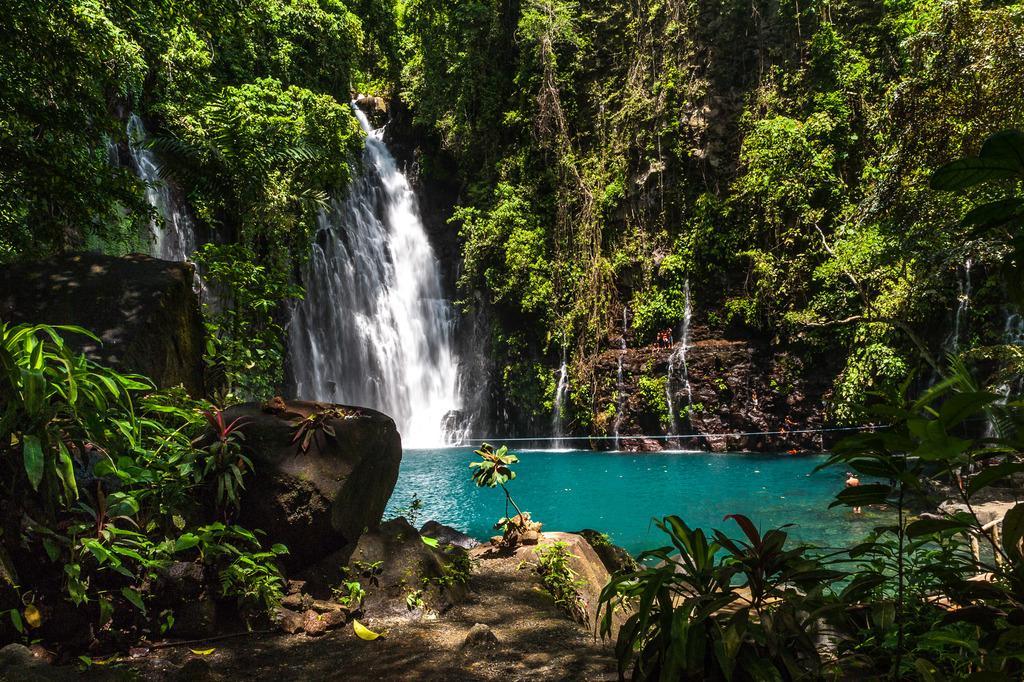How would you summarize this image in a sentence or two? In this picture there is a person standing in the water and there is a waterfall and there are trees on the hill. At the bottom there is water. At the back there might be group of people standing on the hill. 